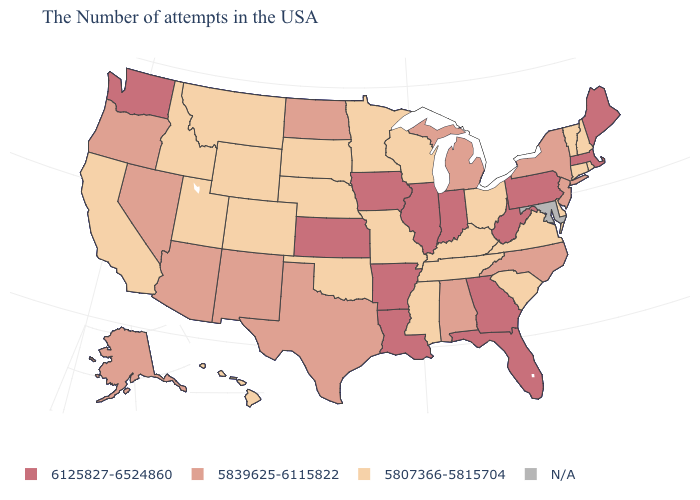How many symbols are there in the legend?
Quick response, please. 4. What is the value of South Dakota?
Keep it brief. 5807366-5815704. What is the lowest value in states that border Massachusetts?
Quick response, please. 5807366-5815704. What is the value of Wyoming?
Quick response, please. 5807366-5815704. Does the map have missing data?
Give a very brief answer. Yes. What is the value of Washington?
Keep it brief. 6125827-6524860. Which states have the lowest value in the USA?
Give a very brief answer. Rhode Island, New Hampshire, Vermont, Connecticut, Delaware, Virginia, South Carolina, Ohio, Kentucky, Tennessee, Wisconsin, Mississippi, Missouri, Minnesota, Nebraska, Oklahoma, South Dakota, Wyoming, Colorado, Utah, Montana, Idaho, California, Hawaii. What is the highest value in states that border Tennessee?
Be succinct. 6125827-6524860. Is the legend a continuous bar?
Write a very short answer. No. Name the states that have a value in the range N/A?
Answer briefly. Maryland. What is the lowest value in the USA?
Answer briefly. 5807366-5815704. What is the value of Florida?
Answer briefly. 6125827-6524860. Does Connecticut have the lowest value in the Northeast?
Keep it brief. Yes. Does the first symbol in the legend represent the smallest category?
Concise answer only. No. 